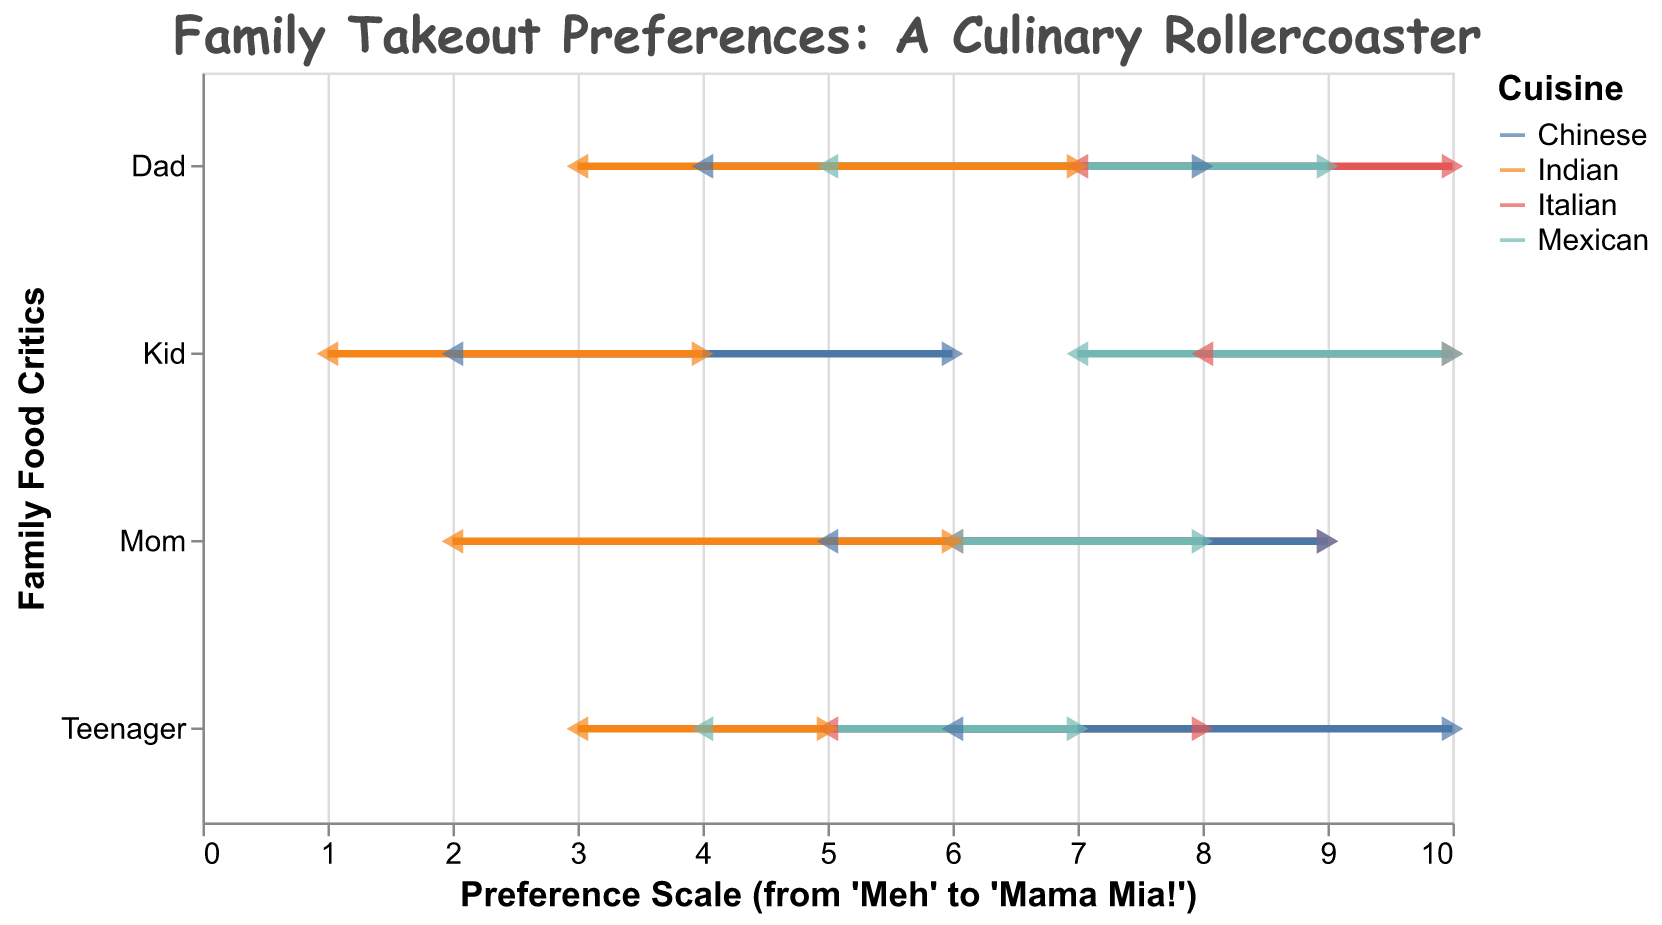what's the title of the plot? The plot's title is positioned at the top. Reading it will give an idea of what the plot is about. The title uses a Comic Sans MS font for a humorous touch: "Family Takeout Preferences: A Culinary Rollercoaster."
Answer: Family Takeout Preferences: A Culinary Rollercoaster what's the range of preferences for Italian cuisine for "Mom"? Locate "Mom" along the y-axis and find the range corresponding to Italian cuisine. The plot shows this range as a line segment. By observing the start and end of the line, you can determine the min and max preference values.
Answer: 6 to 9 which family member has the lowest preference for Indian cuisine? Locate the dots at the lowest preference values for Indian cuisine on the x-axis for each family member. Compare these values to identify the family member with the lowest minimum preference.
Answer: Kid how many cuisine types are compared in the plot? Look at the legend or the different lines and points in various colors representing each cuisine type. Count these distinct entries to find the number of cuisine types.
Answer: 4 who prefers Chinese cuisine the most, according to the maximum preference value? Locate the maximum preference values for Chinese cuisine across all family members. The person with the highest value for this cuisine is the one with the greatest preference.
Answer: Teenager what is the preference range for Mexican cuisine for the "Dad"? Find "Dad" on the y-axis and locate the range for Mexican cuisine. The line segment will show the start and end points (min and max preferences).
Answer: 5 to 9 compare Kid's preference range for Italian and Indian cuisines. Which range is wider? Locate the Kid's preference ranges for both Italian and Indian cuisines on the x-axis. Calculate the difference between the max and min values for both cuisines. Compare these differences to determine which range is wider.
Answer: Italian (2 vs. 3) for which cuisine type does Teenager have the smallest range of preferences? Identify Teenager's preference ranges for all cuisines. Calculate the width of each range (max - min). The cuisine with the smallest difference is the answer.
Answer: Indian what can we infer from the preference ranges about Kid's attitude toward Indian cuisine? Observe Kid's preference range for Indian cuisine, which is the smallest among all family members. It indicates a general disinterest or consistent low preference for Indian cuisine.
Answer: Consistent low preference 